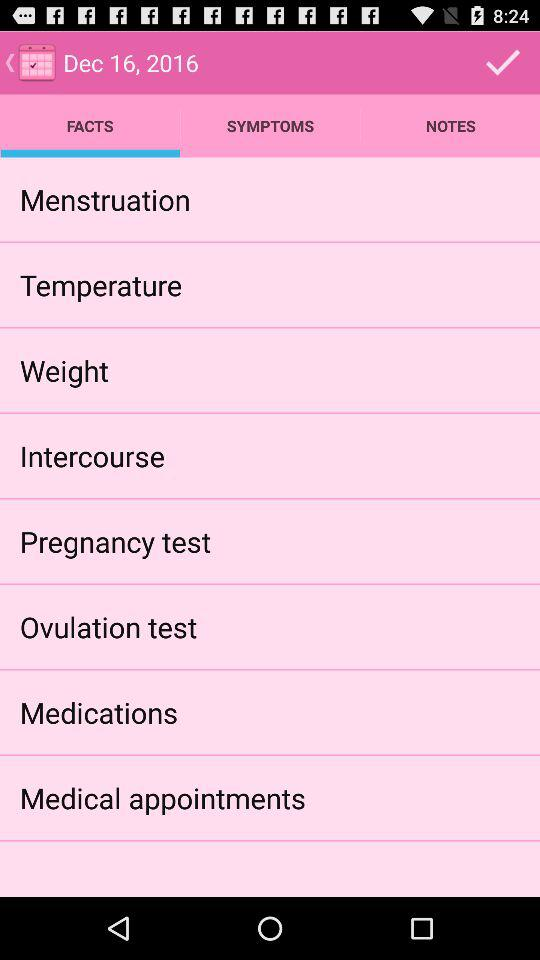Which tab has been selected? The selected tab is "FACTS". 